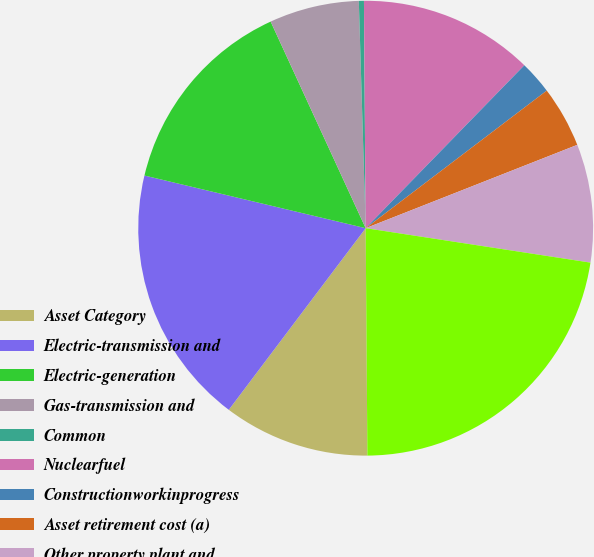Convert chart. <chart><loc_0><loc_0><loc_500><loc_500><pie_chart><fcel>Asset Category<fcel>Electric-transmission and<fcel>Electric-generation<fcel>Gas-transmission and<fcel>Common<fcel>Nuclearfuel<fcel>Constructionworkinprogress<fcel>Asset retirement cost (a)<fcel>Other property plant and<fcel>Total property plant and<nl><fcel>10.4%<fcel>18.44%<fcel>14.42%<fcel>6.38%<fcel>0.36%<fcel>12.41%<fcel>2.37%<fcel>4.37%<fcel>8.39%<fcel>22.46%<nl></chart> 